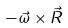<formula> <loc_0><loc_0><loc_500><loc_500>- \vec { \omega } \times \vec { R }</formula> 